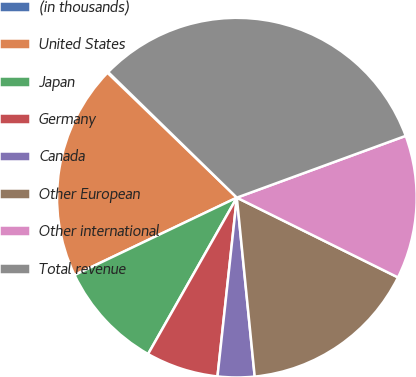<chart> <loc_0><loc_0><loc_500><loc_500><pie_chart><fcel>(in thousands)<fcel>United States<fcel>Japan<fcel>Germany<fcel>Canada<fcel>Other European<fcel>Other international<fcel>Total revenue<nl><fcel>0.09%<fcel>19.3%<fcel>9.7%<fcel>6.5%<fcel>3.3%<fcel>16.1%<fcel>12.9%<fcel>32.11%<nl></chart> 